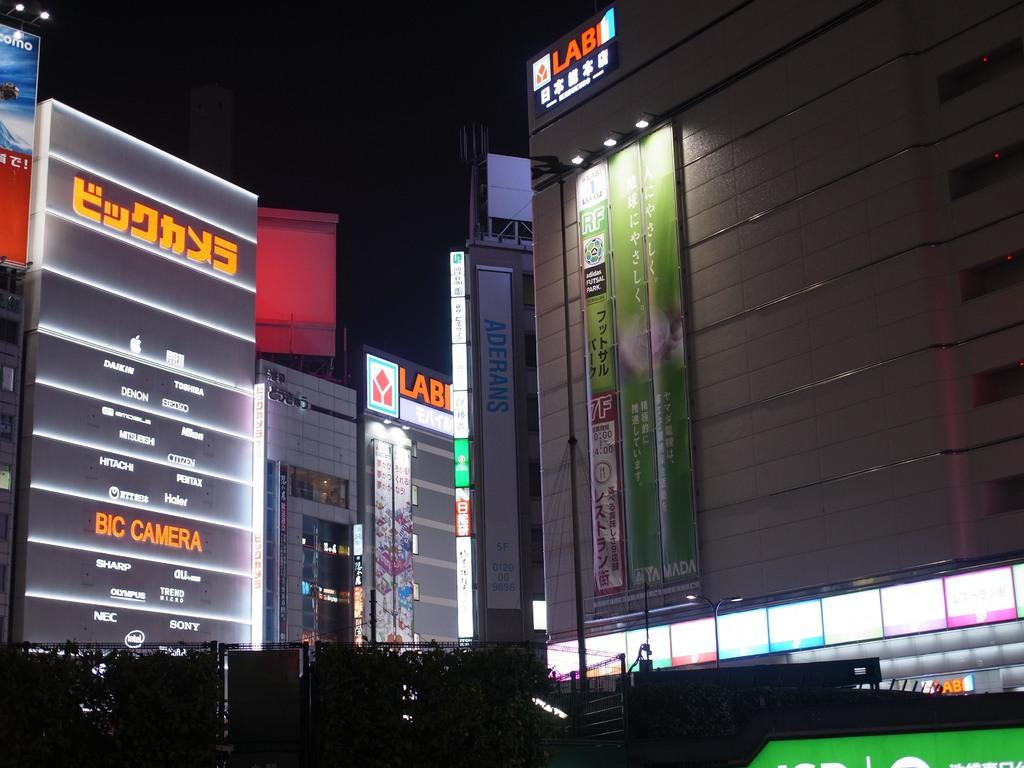What is the lighting condition in the image? The image was taken in the dark. What type of structures can be seen in the image? There are buildings visible in the image. Are there any illuminated signs in the image? Yes, there are name boards with lights in the image. Who is the owner of the ghost in the image? There is no ghost present in the image, so it is not possible to determine the owner. 